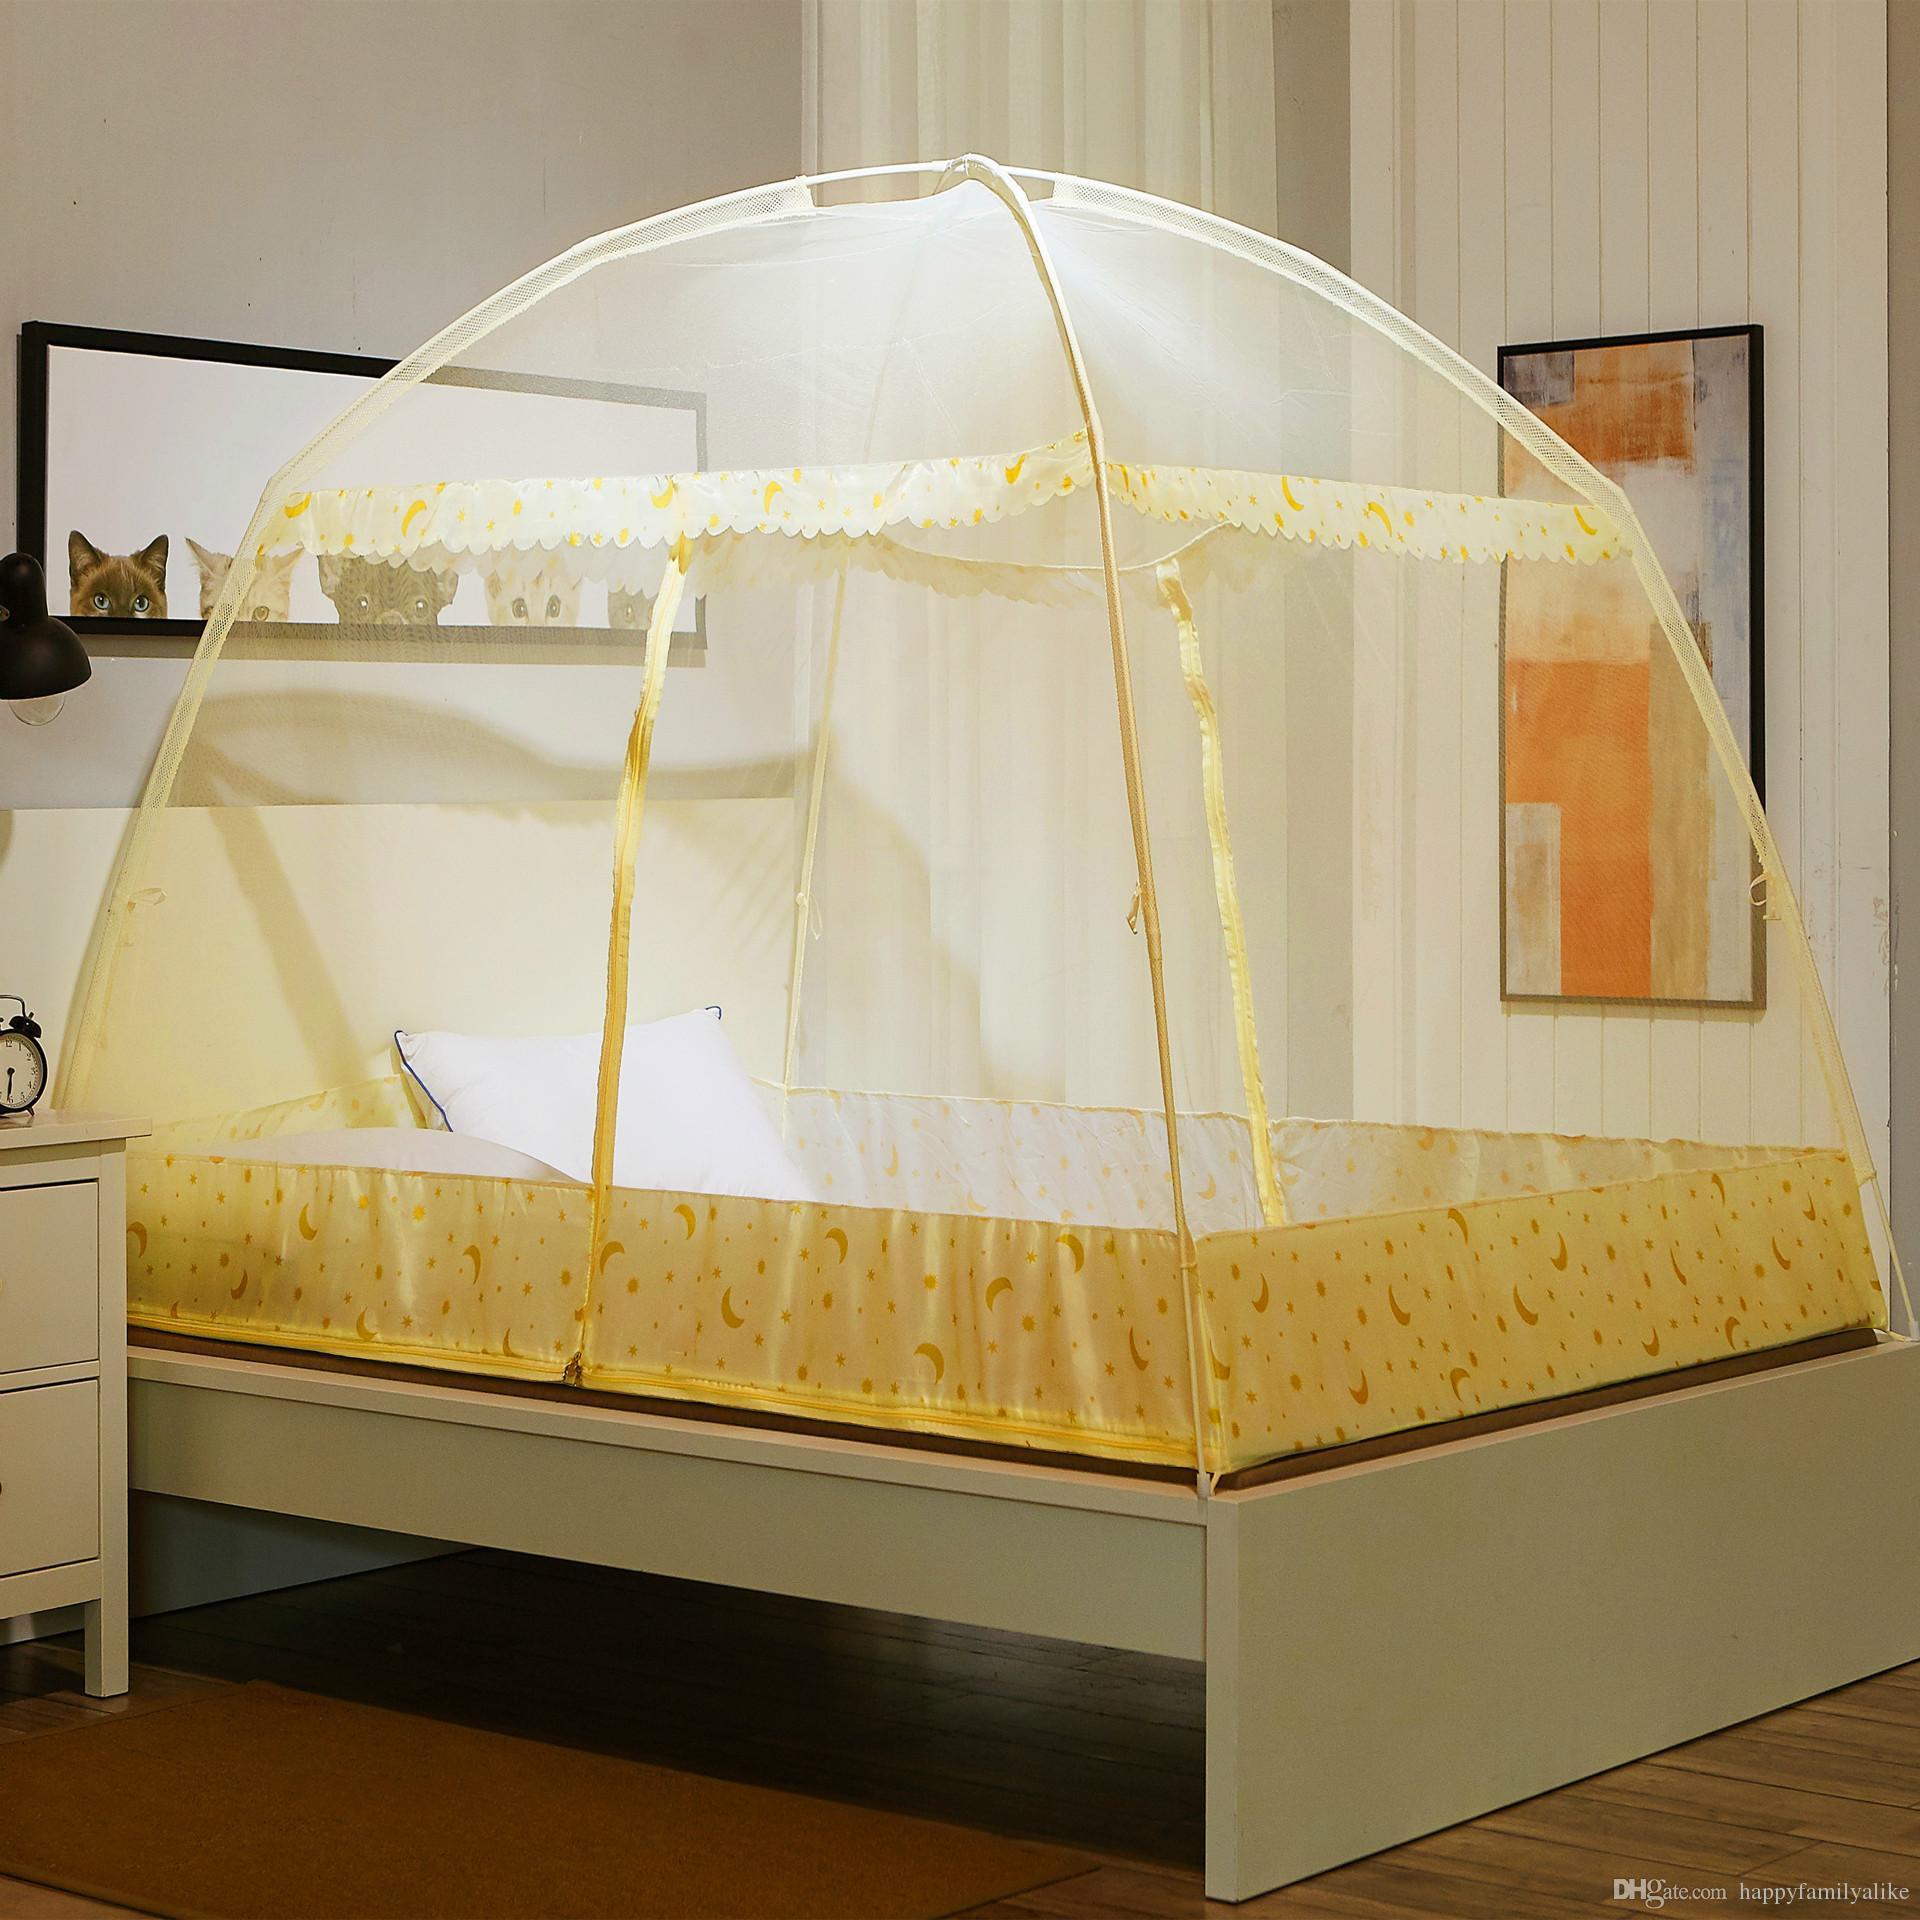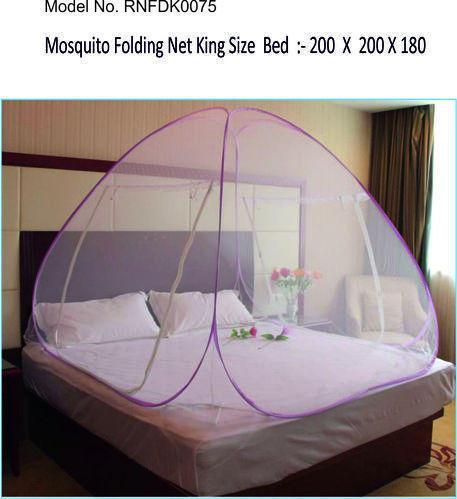The first image is the image on the left, the second image is the image on the right. Evaluate the accuracy of this statement regarding the images: "One bed net has a fabric bottom trim.". Is it true? Answer yes or no. Yes. The first image is the image on the left, the second image is the image on the right. Given the left and right images, does the statement "Each image shows a canopy with a dome top and trim in a shade of blue over a bed with no one on it." hold true? Answer yes or no. No. 